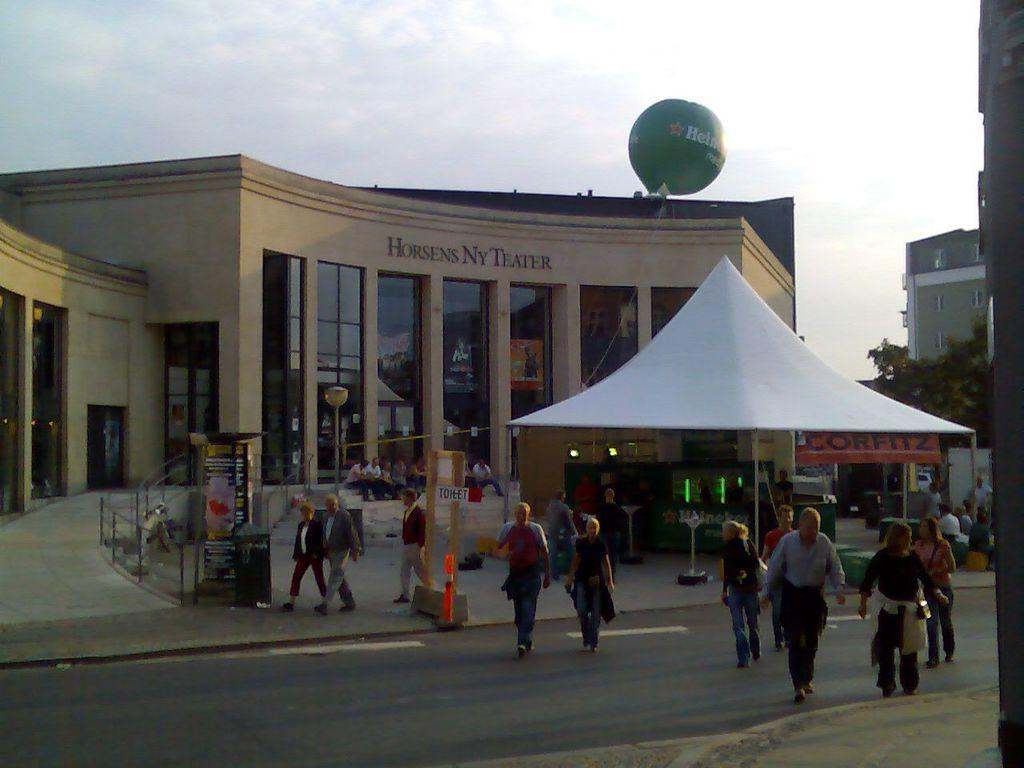What are the people in the image doing? There are persons walking in the image. What can be seen in the background behind the people? There is a building behind the persons. What type of vegetation is present in the image? There is a tree in the image. Where is another building located in the image? There is a building in the right corner of the image. What type of trick can be seen being performed with the edge of the building in the image? There is no trick being performed with the edge of the building in the image. 